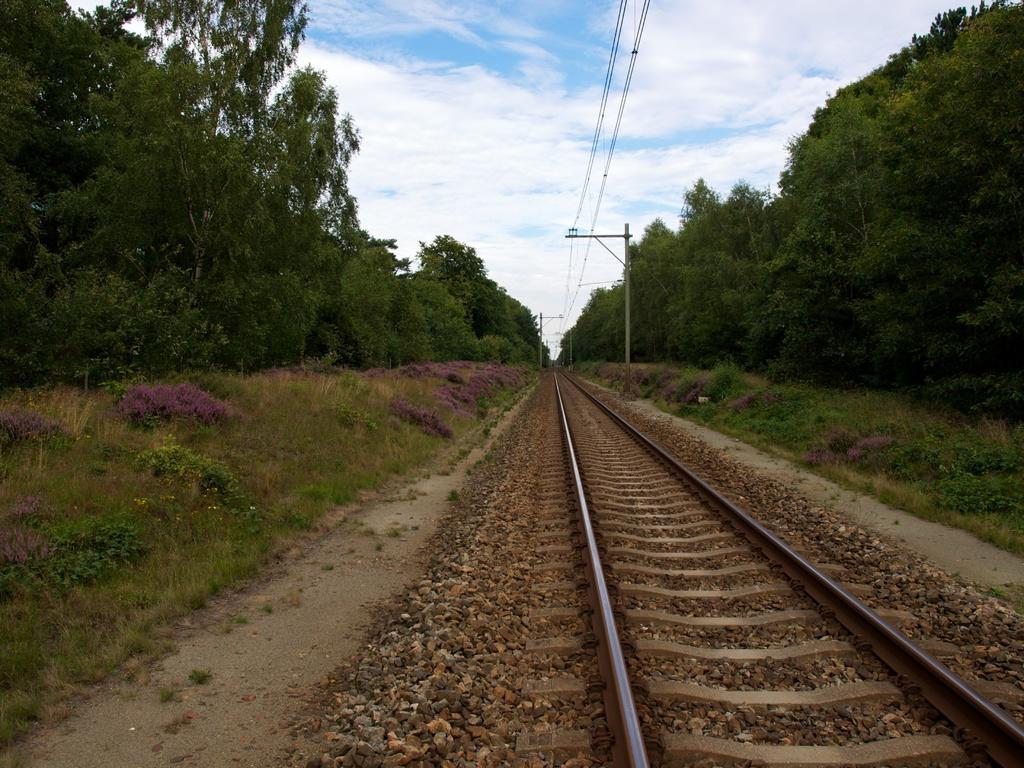What type of transportation infrastructure is visible in the image? There is a railway track in the image. What type of vegetation can be seen in the image? Plants, grass, and trees are visible in the image. What object is present in the image that might be used for support or attachment? There is a pole in the image. What is visible in the background of the image? The sky is visible in the background of the image. What can be observed in the sky in the image? Clouds are present in the sky. What type of sock is the tree wearing in the image? There are no socks present in the image, as trees do not wear clothing. 